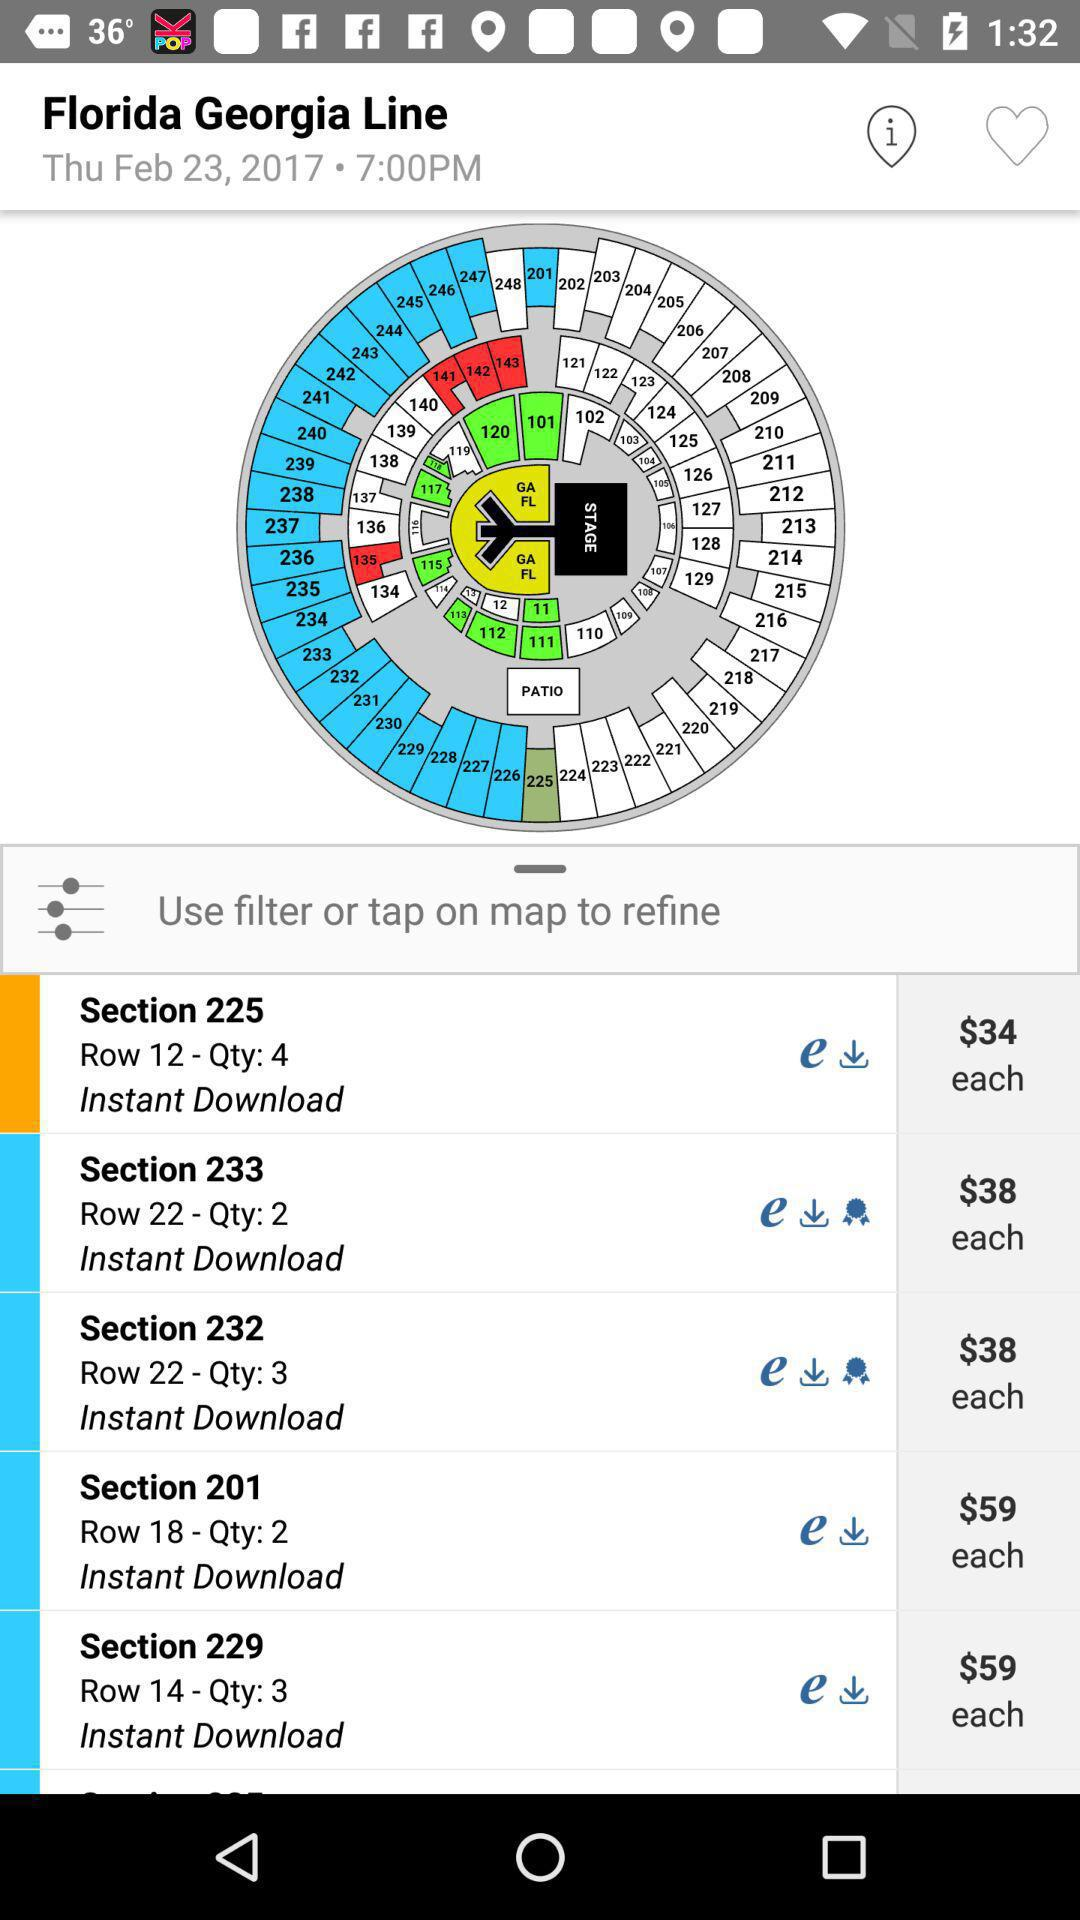How many rows are there in "Section 232"? There are 22 rows in "Section 232". 